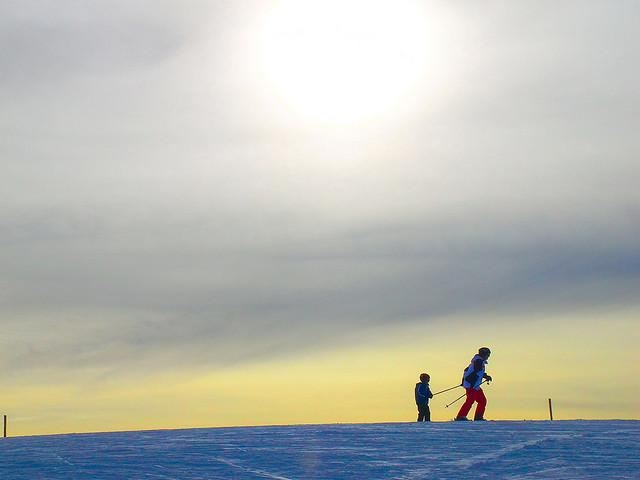What is the father doing with the child out on the mountain?

Choices:
A) teaching
B) transporting
C) pulling
D) hunting teaching 